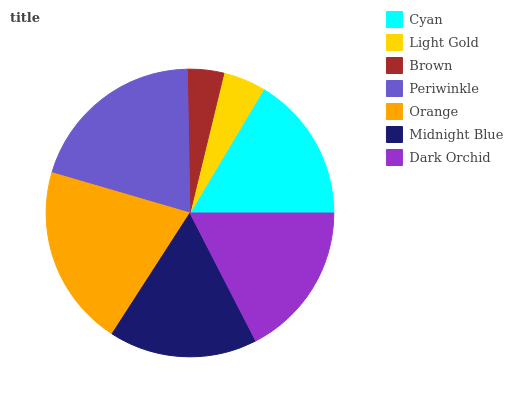Is Brown the minimum?
Answer yes or no. Yes. Is Orange the maximum?
Answer yes or no. Yes. Is Light Gold the minimum?
Answer yes or no. No. Is Light Gold the maximum?
Answer yes or no. No. Is Cyan greater than Light Gold?
Answer yes or no. Yes. Is Light Gold less than Cyan?
Answer yes or no. Yes. Is Light Gold greater than Cyan?
Answer yes or no. No. Is Cyan less than Light Gold?
Answer yes or no. No. Is Midnight Blue the high median?
Answer yes or no. Yes. Is Midnight Blue the low median?
Answer yes or no. Yes. Is Light Gold the high median?
Answer yes or no. No. Is Light Gold the low median?
Answer yes or no. No. 